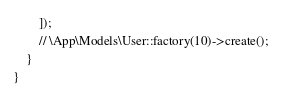<code> <loc_0><loc_0><loc_500><loc_500><_PHP_>        ]);
        // \App\Models\User::factory(10)->create();
    }
}
</code> 